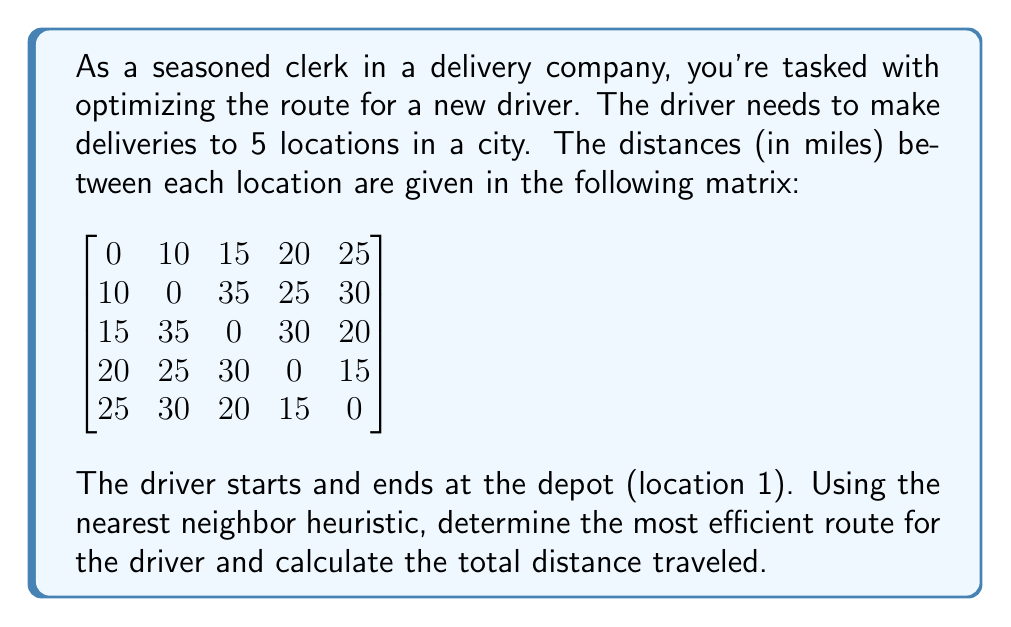What is the answer to this math problem? To solve this problem using the nearest neighbor heuristic, we'll follow these steps:

1. Start at the depot (location 1).
2. Find the nearest unvisited location.
3. Move to that location.
4. Repeat steps 2-3 until all locations have been visited.
5. Return to the depot.

Let's go through the process:

1. Start at location 1 (depot).

2. Find the nearest location to 1:
   Location 2: 10 miles
   Location 3: 15 miles
   Location 4: 20 miles
   Location 5: 25 miles
   The nearest is location 2 (10 miles).

3. Move to location 2. Distance so far: 10 miles.

4. Find the nearest unvisited location to 2:
   Location 3: 35 miles
   Location 4: 25 miles
   Location 5: 30 miles
   The nearest is location 4 (25 miles).

5. Move to location 4. Distance so far: 10 + 25 = 35 miles.

6. Find the nearest unvisited location to 4:
   Location 3: 30 miles
   Location 5: 15 miles
   The nearest is location 5 (15 miles).

7. Move to location 5. Distance so far: 35 + 15 = 50 miles.

8. The only unvisited location is 3, so move there.
   Distance from 5 to 3: 20 miles.
   Distance so far: 50 + 20 = 70 miles.

9. Return to the depot (location 1) from location 3.
   Distance from 3 to 1: 15 miles.
   Total distance: 70 + 15 = 85 miles.

The most efficient route using the nearest neighbor heuristic is:
1 → 2 → 4 → 5 → 3 → 1

The total distance traveled is 85 miles.
Answer: The most efficient route: 1 → 2 → 4 → 5 → 3 → 1
Total distance: 85 miles 